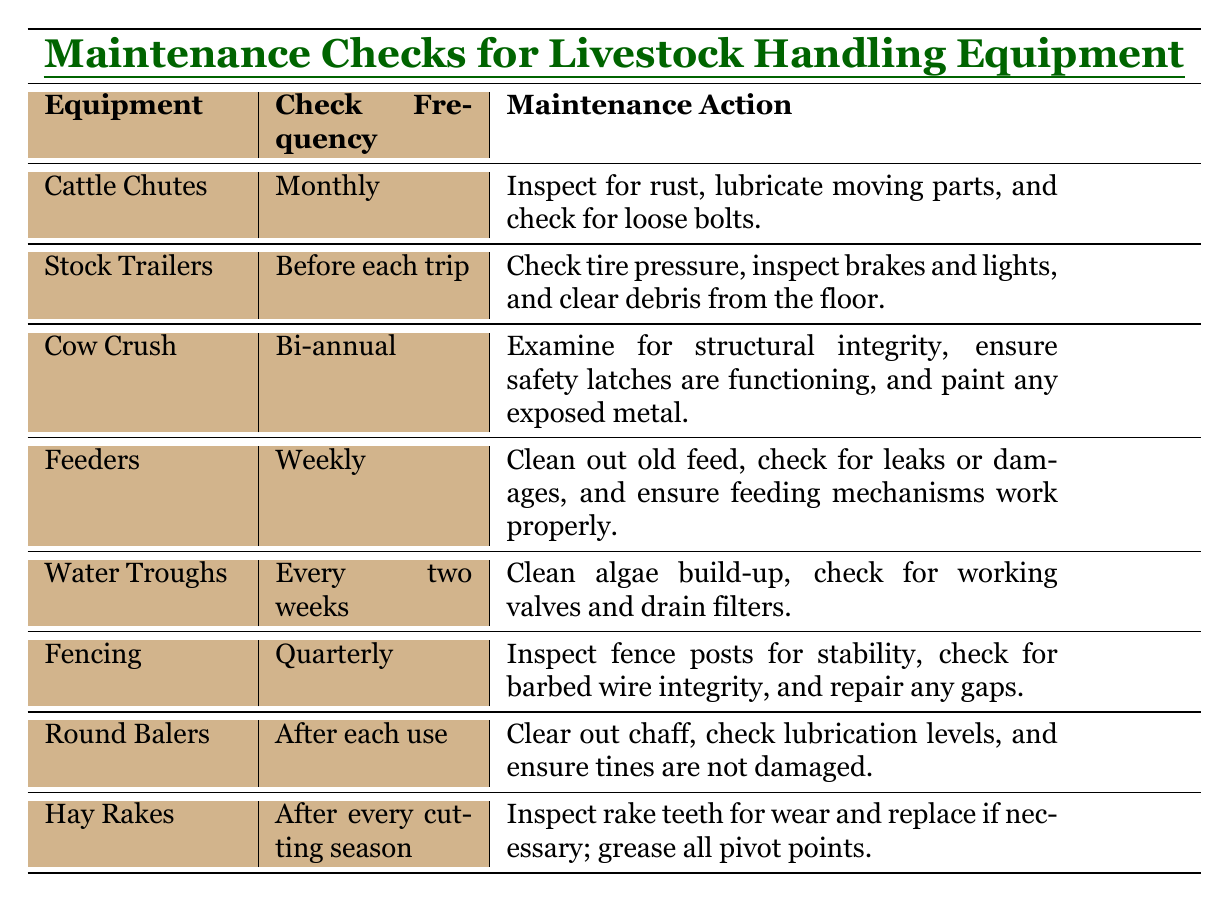What is the maintenance action for Cattle Chutes? According to the table, the maintenance action for Cattle Chutes includes inspecting for rust, lubricating moving parts, and checking for loose bolts.
Answer: Inspect for rust, lubricate moving parts, check for loose bolts How often do you need to check the Water Troughs? The table states that Water Troughs need to be checked every two weeks.
Answer: Every two weeks Are Round Balers checked before each use? The table indicates that Round Balers are inspected after each use, not before, which makes this statement false.
Answer: No What is the frequency of maintenance checks for Feeders? The table shows that Feeders require weekly maintenance checks.
Answer: Weekly How many different maintenance actions are listed in the table? There are eight distinct maintenance actions listed for various equipment in the table.
Answer: Eight What is the longest interval for maintenance checks among the equipment listed? The Cow Crush requires maintenance checks bi-annually, which is the longest interval compared to others like monthly or quarterly checks.
Answer: Bi-annual If a rancher checks Fencing quarterly, how many times would that amount to in a year? Since a year has four quarters, a rancher would perform maintenance checks on Fencing four times in a year.
Answer: Four times Which equipment requires a maintenance check after every cutting season? The table specifies that Hay Rakes need a maintenance check after every cutting season.
Answer: Hay Rakes If a rancher checks Feeders weekly, how many total checks will be done in a month? There are approximately four weeks in a month, so checking Feeders weekly would result in about 4 checks per month.
Answer: Four checks Which piece of equipment needs to be checked immediately before use? The table indicates that Stock Trailers must be checked before each trip, making it the piece of equipment that requires immediate pre-use checks.
Answer: Stock Trailers 